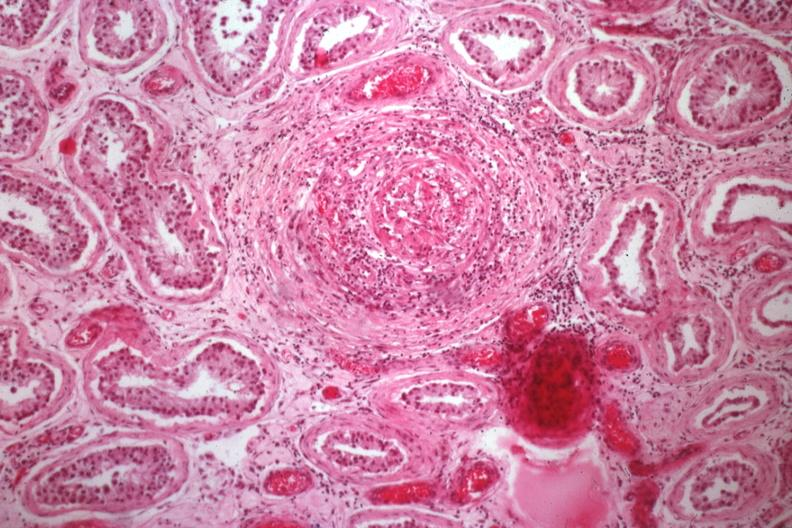does this image show medium size artery with obvious vasculitis?
Answer the question using a single word or phrase. Yes 